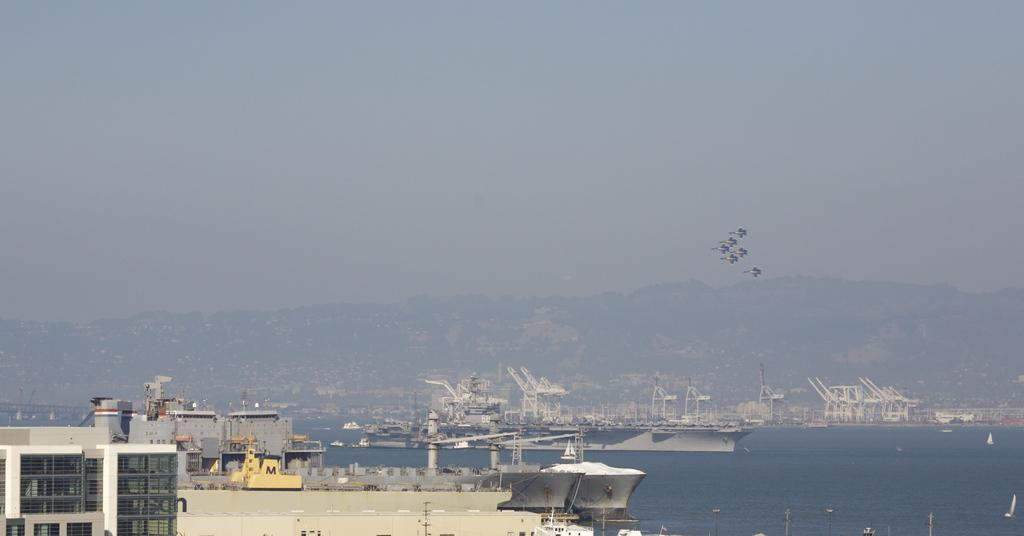What types of vehicles are on the water in the image? There are ships and boats on the water in the image. What structure can be seen in the image? There is a building visible in the image. What animals are flying in the air in the image? Birds are flying in the air in the image. What natural feature is visible in the background of the image? There is a mountain in the background of the image. What else can be seen in the background of the image? The sky is visible in the background of the image. What organization is responsible for the idea of the mountain in the image? There is no organization mentioned or implied in the image, and the mountain is a natural feature, not an idea. 